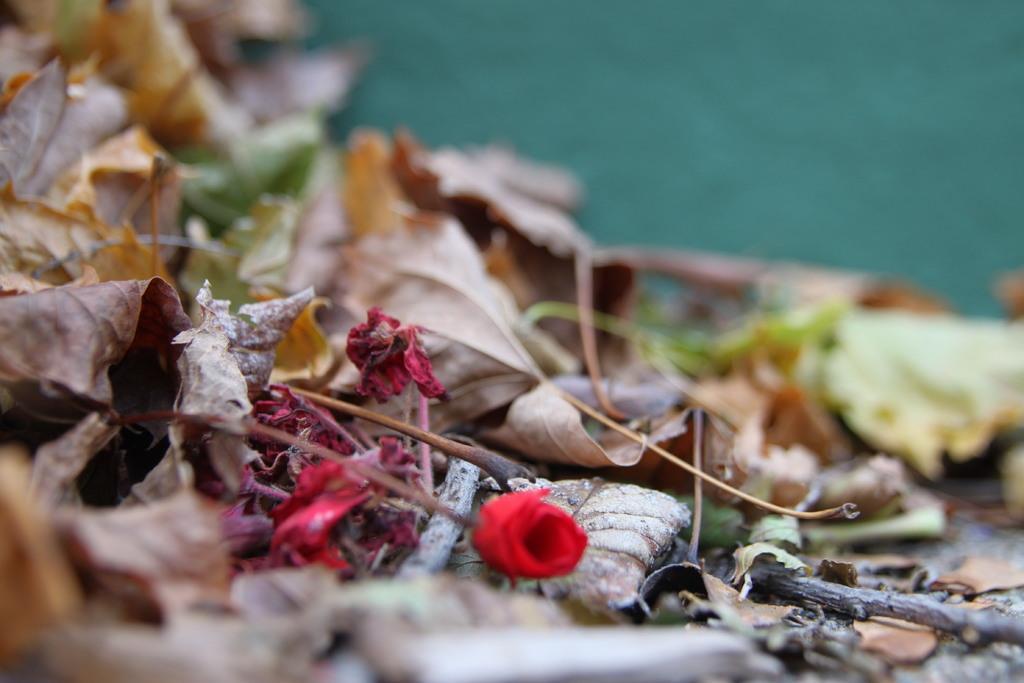Can you describe this image briefly? In this image, we can see a red flower with stem. Here there are few dry leaves, sticks. Background there is a blur view. 